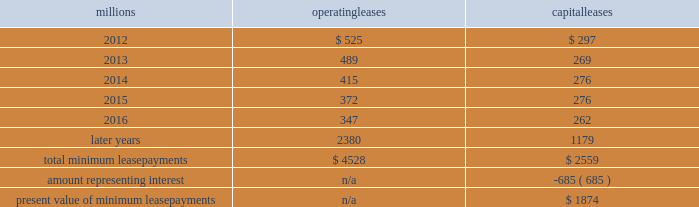The redemptions resulted in an early extinguishment charge of $ 5 million .
On march 22 , 2010 , we redeemed $ 175 million of our 6.5% ( 6.5 % ) notes due april 15 , 2012 .
The redemption resulted in an early extinguishment charge of $ 16 million in the first quarter of 2010 .
On november 1 , 2010 , we redeemed all $ 400 million of our outstanding 6.65% ( 6.65 % ) notes due january 15 , 2011 .
The redemption resulted in a $ 5 million early extinguishment charge .
Receivables securitization facility 2013 as of december 31 , 2011 and 2010 , we have recorded $ 100 million as secured debt under our receivables securitization facility .
( see further discussion of our receivables securitization facility in note 10 ) .
15 .
Variable interest entities we have entered into various lease transactions in which the structure of the leases contain variable interest entities ( vies ) .
These vies were created solely for the purpose of doing lease transactions ( principally involving railroad equipment and facilities , including our headquarters building ) and have no other activities , assets or liabilities outside of the lease transactions .
Within these lease arrangements , we have the right to purchase some or all of the assets at fixed prices .
Depending on market conditions , fixed-price purchase options available in the leases could potentially provide benefits to us ; however , these benefits are not expected to be significant .
We maintain and operate the assets based on contractual obligations within the lease arrangements , which set specific guidelines consistent within the railroad industry .
As such , we have no control over activities that could materially impact the fair value of the leased assets .
We do not hold the power to direct the activities of the vies and , therefore , do not control the ongoing activities that have a significant impact on the economic performance of the vies .
Additionally , we do not have the obligation to absorb losses of the vies or the right to receive benefits of the vies that could potentially be significant to the we are not considered to be the primary beneficiary and do not consolidate these vies because our actions and decisions do not have the most significant effect on the vie 2019s performance and our fixed-price purchase price options are not considered to be potentially significant to the vie 2019s .
The future minimum lease payments associated with the vie leases totaled $ 3.9 billion as of december 31 , 2011 .
16 .
Leases we lease certain locomotives , freight cars , and other property .
The consolidated statement of financial position as of december 31 , 2011 and 2010 included $ 2458 million , net of $ 915 million of accumulated depreciation , and $ 2520 million , net of $ 901 million of accumulated depreciation , respectively , for properties held under capital leases .
A charge to income resulting from the depreciation for assets held under capital leases is included within depreciation expense in our consolidated statements of income .
Future minimum lease payments for operating and capital leases with initial or remaining non-cancelable lease terms in excess of one year as of december 31 , 2011 , were as follows : millions operating leases capital leases .
The majority of capital lease payments relate to locomotives .
Rent expense for operating leases with terms exceeding one month was $ 637 million in 2011 , $ 624 million in 2010 , and $ 686 million in 2009 .
When cash rental payments are not made on a straight-line basis , we recognize variable rental expense on a straight-line basis over the lease term .
Contingent rentals and sub-rentals are not significant. .
Did the annual interest savings on the redemption of the 6.5% ( 6.5 % ) notes exceed the cost of the early extinguishment? 
Computations: ((175 * 6.5%) > 16)
Answer: no. 